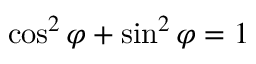<formula> <loc_0><loc_0><loc_500><loc_500>\cos ^ { 2 } \varphi + \sin ^ { 2 } \varphi = 1</formula> 